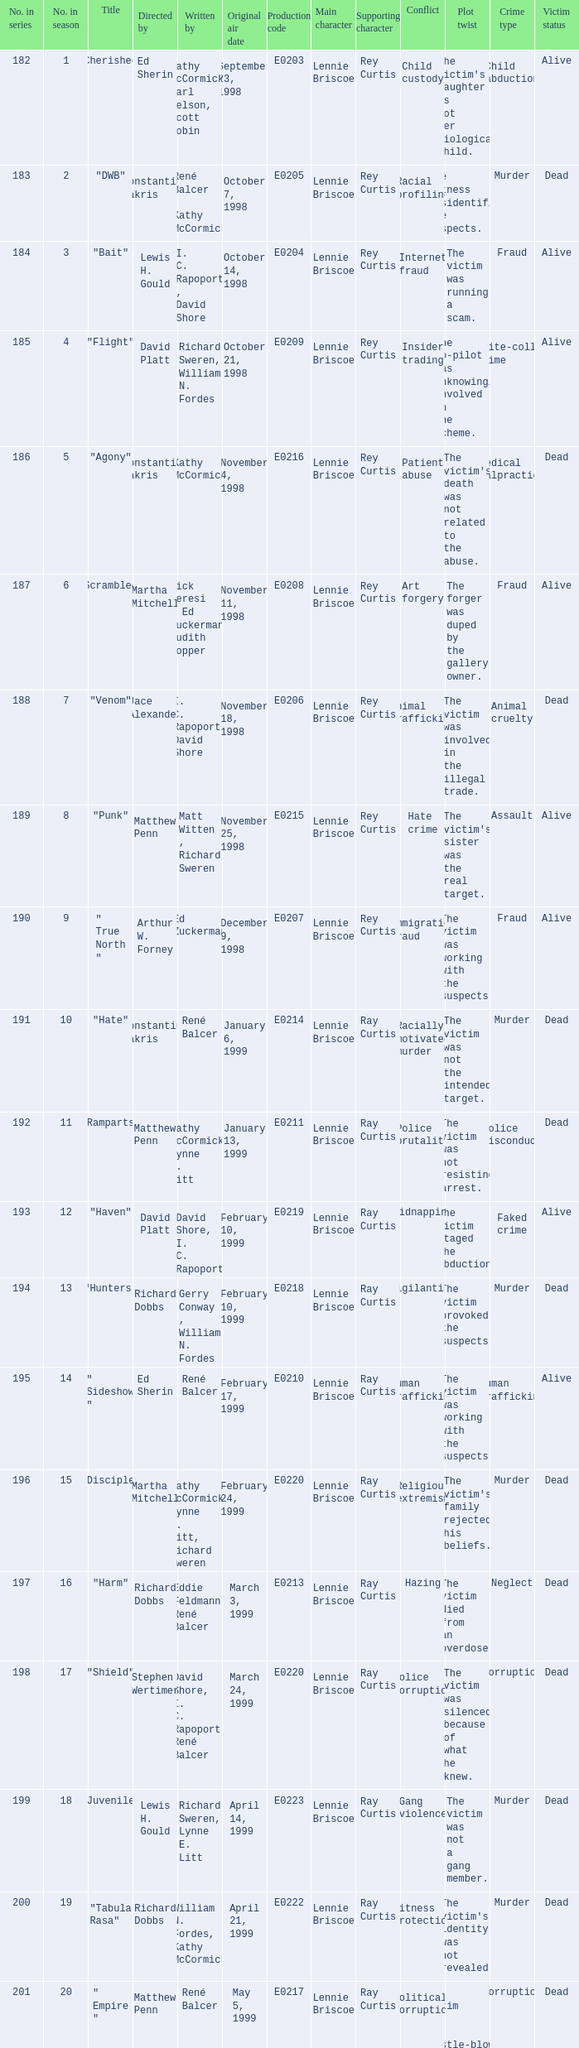The episode with the title "Bait" has what original air date? October 14, 1998. 